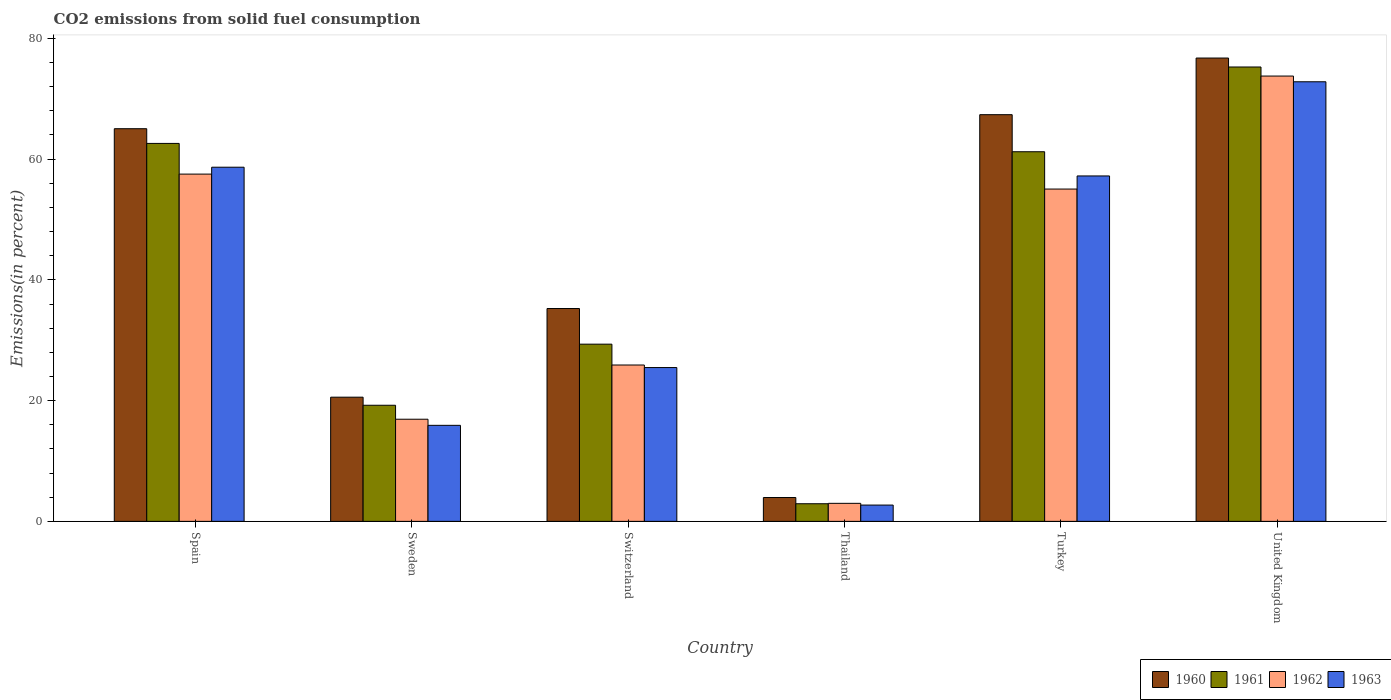How many different coloured bars are there?
Keep it short and to the point. 4. How many groups of bars are there?
Offer a terse response. 6. Are the number of bars per tick equal to the number of legend labels?
Offer a terse response. Yes. In how many cases, is the number of bars for a given country not equal to the number of legend labels?
Offer a very short reply. 0. What is the total CO2 emitted in 1961 in Sweden?
Provide a short and direct response. 19.23. Across all countries, what is the maximum total CO2 emitted in 1960?
Keep it short and to the point. 76.74. Across all countries, what is the minimum total CO2 emitted in 1960?
Provide a short and direct response. 3.95. In which country was the total CO2 emitted in 1962 maximum?
Offer a very short reply. United Kingdom. In which country was the total CO2 emitted in 1963 minimum?
Provide a short and direct response. Thailand. What is the total total CO2 emitted in 1960 in the graph?
Offer a very short reply. 268.92. What is the difference between the total CO2 emitted in 1960 in Switzerland and that in United Kingdom?
Your answer should be compact. -41.49. What is the difference between the total CO2 emitted in 1962 in Thailand and the total CO2 emitted in 1961 in Spain?
Make the answer very short. -59.62. What is the average total CO2 emitted in 1960 per country?
Give a very brief answer. 44.82. What is the difference between the total CO2 emitted of/in 1962 and total CO2 emitted of/in 1963 in Switzerland?
Offer a terse response. 0.42. In how many countries, is the total CO2 emitted in 1961 greater than 68 %?
Offer a terse response. 1. What is the ratio of the total CO2 emitted in 1961 in Switzerland to that in United Kingdom?
Make the answer very short. 0.39. What is the difference between the highest and the second highest total CO2 emitted in 1960?
Keep it short and to the point. -2.33. What is the difference between the highest and the lowest total CO2 emitted in 1960?
Offer a terse response. 72.8. In how many countries, is the total CO2 emitted in 1963 greater than the average total CO2 emitted in 1963 taken over all countries?
Provide a short and direct response. 3. Is the sum of the total CO2 emitted in 1962 in Spain and Sweden greater than the maximum total CO2 emitted in 1960 across all countries?
Your response must be concise. No. Is it the case that in every country, the sum of the total CO2 emitted in 1960 and total CO2 emitted in 1961 is greater than the sum of total CO2 emitted in 1962 and total CO2 emitted in 1963?
Keep it short and to the point. No. What does the 1st bar from the right in Thailand represents?
Your answer should be very brief. 1963. Is it the case that in every country, the sum of the total CO2 emitted in 1962 and total CO2 emitted in 1963 is greater than the total CO2 emitted in 1960?
Keep it short and to the point. Yes. How many bars are there?
Keep it short and to the point. 24. Are all the bars in the graph horizontal?
Offer a terse response. No. What is the difference between two consecutive major ticks on the Y-axis?
Your answer should be very brief. 20. Are the values on the major ticks of Y-axis written in scientific E-notation?
Provide a short and direct response. No. Does the graph contain any zero values?
Provide a succinct answer. No. Does the graph contain grids?
Ensure brevity in your answer.  No. Where does the legend appear in the graph?
Your answer should be very brief. Bottom right. How many legend labels are there?
Offer a terse response. 4. What is the title of the graph?
Keep it short and to the point. CO2 emissions from solid fuel consumption. Does "1979" appear as one of the legend labels in the graph?
Keep it short and to the point. No. What is the label or title of the Y-axis?
Your response must be concise. Emissions(in percent). What is the Emissions(in percent) in 1960 in Spain?
Your response must be concise. 65.04. What is the Emissions(in percent) of 1961 in Spain?
Ensure brevity in your answer.  62.6. What is the Emissions(in percent) of 1962 in Spain?
Provide a short and direct response. 57.52. What is the Emissions(in percent) of 1963 in Spain?
Offer a very short reply. 58.66. What is the Emissions(in percent) of 1960 in Sweden?
Ensure brevity in your answer.  20.57. What is the Emissions(in percent) in 1961 in Sweden?
Ensure brevity in your answer.  19.23. What is the Emissions(in percent) in 1962 in Sweden?
Offer a very short reply. 16.92. What is the Emissions(in percent) of 1963 in Sweden?
Provide a short and direct response. 15.91. What is the Emissions(in percent) in 1960 in Switzerland?
Your response must be concise. 35.26. What is the Emissions(in percent) in 1961 in Switzerland?
Your response must be concise. 29.35. What is the Emissions(in percent) in 1962 in Switzerland?
Offer a terse response. 25.9. What is the Emissions(in percent) in 1963 in Switzerland?
Ensure brevity in your answer.  25.48. What is the Emissions(in percent) in 1960 in Thailand?
Your response must be concise. 3.95. What is the Emissions(in percent) in 1961 in Thailand?
Your answer should be compact. 2.92. What is the Emissions(in percent) of 1962 in Thailand?
Offer a terse response. 2.99. What is the Emissions(in percent) of 1963 in Thailand?
Offer a terse response. 2.7. What is the Emissions(in percent) of 1960 in Turkey?
Offer a terse response. 67.36. What is the Emissions(in percent) in 1961 in Turkey?
Offer a terse response. 61.22. What is the Emissions(in percent) in 1962 in Turkey?
Your answer should be compact. 55.04. What is the Emissions(in percent) in 1963 in Turkey?
Provide a short and direct response. 57.21. What is the Emissions(in percent) in 1960 in United Kingdom?
Make the answer very short. 76.74. What is the Emissions(in percent) of 1961 in United Kingdom?
Your answer should be very brief. 75.26. What is the Emissions(in percent) in 1962 in United Kingdom?
Offer a very short reply. 73.76. What is the Emissions(in percent) of 1963 in United Kingdom?
Offer a terse response. 72.81. Across all countries, what is the maximum Emissions(in percent) in 1960?
Give a very brief answer. 76.74. Across all countries, what is the maximum Emissions(in percent) in 1961?
Ensure brevity in your answer.  75.26. Across all countries, what is the maximum Emissions(in percent) in 1962?
Offer a terse response. 73.76. Across all countries, what is the maximum Emissions(in percent) of 1963?
Your answer should be very brief. 72.81. Across all countries, what is the minimum Emissions(in percent) in 1960?
Your answer should be very brief. 3.95. Across all countries, what is the minimum Emissions(in percent) of 1961?
Give a very brief answer. 2.92. Across all countries, what is the minimum Emissions(in percent) of 1962?
Your response must be concise. 2.99. Across all countries, what is the minimum Emissions(in percent) in 1963?
Offer a very short reply. 2.7. What is the total Emissions(in percent) of 1960 in the graph?
Provide a short and direct response. 268.92. What is the total Emissions(in percent) of 1961 in the graph?
Provide a succinct answer. 250.59. What is the total Emissions(in percent) of 1962 in the graph?
Your answer should be very brief. 232.13. What is the total Emissions(in percent) in 1963 in the graph?
Offer a very short reply. 232.77. What is the difference between the Emissions(in percent) in 1960 in Spain and that in Sweden?
Keep it short and to the point. 44.47. What is the difference between the Emissions(in percent) in 1961 in Spain and that in Sweden?
Keep it short and to the point. 43.37. What is the difference between the Emissions(in percent) in 1962 in Spain and that in Sweden?
Give a very brief answer. 40.6. What is the difference between the Emissions(in percent) of 1963 in Spain and that in Sweden?
Give a very brief answer. 42.75. What is the difference between the Emissions(in percent) of 1960 in Spain and that in Switzerland?
Keep it short and to the point. 29.78. What is the difference between the Emissions(in percent) of 1961 in Spain and that in Switzerland?
Make the answer very short. 33.25. What is the difference between the Emissions(in percent) of 1962 in Spain and that in Switzerland?
Keep it short and to the point. 31.62. What is the difference between the Emissions(in percent) in 1963 in Spain and that in Switzerland?
Offer a terse response. 33.19. What is the difference between the Emissions(in percent) in 1960 in Spain and that in Thailand?
Provide a short and direct response. 61.09. What is the difference between the Emissions(in percent) of 1961 in Spain and that in Thailand?
Your answer should be very brief. 59.69. What is the difference between the Emissions(in percent) of 1962 in Spain and that in Thailand?
Provide a short and direct response. 54.53. What is the difference between the Emissions(in percent) in 1963 in Spain and that in Thailand?
Give a very brief answer. 55.96. What is the difference between the Emissions(in percent) in 1960 in Spain and that in Turkey?
Offer a terse response. -2.33. What is the difference between the Emissions(in percent) in 1961 in Spain and that in Turkey?
Offer a very short reply. 1.38. What is the difference between the Emissions(in percent) of 1962 in Spain and that in Turkey?
Provide a short and direct response. 2.48. What is the difference between the Emissions(in percent) of 1963 in Spain and that in Turkey?
Provide a short and direct response. 1.45. What is the difference between the Emissions(in percent) in 1960 in Spain and that in United Kingdom?
Provide a short and direct response. -11.71. What is the difference between the Emissions(in percent) of 1961 in Spain and that in United Kingdom?
Keep it short and to the point. -12.66. What is the difference between the Emissions(in percent) in 1962 in Spain and that in United Kingdom?
Keep it short and to the point. -16.24. What is the difference between the Emissions(in percent) of 1963 in Spain and that in United Kingdom?
Keep it short and to the point. -14.15. What is the difference between the Emissions(in percent) in 1960 in Sweden and that in Switzerland?
Make the answer very short. -14.69. What is the difference between the Emissions(in percent) of 1961 in Sweden and that in Switzerland?
Your answer should be very brief. -10.12. What is the difference between the Emissions(in percent) in 1962 in Sweden and that in Switzerland?
Your answer should be compact. -8.98. What is the difference between the Emissions(in percent) in 1963 in Sweden and that in Switzerland?
Offer a terse response. -9.57. What is the difference between the Emissions(in percent) in 1960 in Sweden and that in Thailand?
Your response must be concise. 16.62. What is the difference between the Emissions(in percent) of 1961 in Sweden and that in Thailand?
Make the answer very short. 16.31. What is the difference between the Emissions(in percent) in 1962 in Sweden and that in Thailand?
Ensure brevity in your answer.  13.93. What is the difference between the Emissions(in percent) in 1963 in Sweden and that in Thailand?
Keep it short and to the point. 13.21. What is the difference between the Emissions(in percent) of 1960 in Sweden and that in Turkey?
Offer a terse response. -46.8. What is the difference between the Emissions(in percent) of 1961 in Sweden and that in Turkey?
Keep it short and to the point. -41.99. What is the difference between the Emissions(in percent) of 1962 in Sweden and that in Turkey?
Your answer should be compact. -38.13. What is the difference between the Emissions(in percent) of 1963 in Sweden and that in Turkey?
Provide a short and direct response. -41.31. What is the difference between the Emissions(in percent) of 1960 in Sweden and that in United Kingdom?
Keep it short and to the point. -56.18. What is the difference between the Emissions(in percent) of 1961 in Sweden and that in United Kingdom?
Give a very brief answer. -56.03. What is the difference between the Emissions(in percent) in 1962 in Sweden and that in United Kingdom?
Provide a short and direct response. -56.84. What is the difference between the Emissions(in percent) in 1963 in Sweden and that in United Kingdom?
Your answer should be very brief. -56.91. What is the difference between the Emissions(in percent) of 1960 in Switzerland and that in Thailand?
Your answer should be very brief. 31.31. What is the difference between the Emissions(in percent) in 1961 in Switzerland and that in Thailand?
Make the answer very short. 26.43. What is the difference between the Emissions(in percent) in 1962 in Switzerland and that in Thailand?
Offer a very short reply. 22.91. What is the difference between the Emissions(in percent) in 1963 in Switzerland and that in Thailand?
Offer a very short reply. 22.78. What is the difference between the Emissions(in percent) of 1960 in Switzerland and that in Turkey?
Your response must be concise. -32.11. What is the difference between the Emissions(in percent) in 1961 in Switzerland and that in Turkey?
Keep it short and to the point. -31.87. What is the difference between the Emissions(in percent) of 1962 in Switzerland and that in Turkey?
Keep it short and to the point. -29.14. What is the difference between the Emissions(in percent) in 1963 in Switzerland and that in Turkey?
Ensure brevity in your answer.  -31.74. What is the difference between the Emissions(in percent) in 1960 in Switzerland and that in United Kingdom?
Offer a very short reply. -41.49. What is the difference between the Emissions(in percent) of 1961 in Switzerland and that in United Kingdom?
Your answer should be compact. -45.91. What is the difference between the Emissions(in percent) of 1962 in Switzerland and that in United Kingdom?
Make the answer very short. -47.86. What is the difference between the Emissions(in percent) of 1963 in Switzerland and that in United Kingdom?
Provide a short and direct response. -47.34. What is the difference between the Emissions(in percent) of 1960 in Thailand and that in Turkey?
Keep it short and to the point. -63.42. What is the difference between the Emissions(in percent) of 1961 in Thailand and that in Turkey?
Provide a succinct answer. -58.31. What is the difference between the Emissions(in percent) in 1962 in Thailand and that in Turkey?
Give a very brief answer. -52.06. What is the difference between the Emissions(in percent) of 1963 in Thailand and that in Turkey?
Offer a very short reply. -54.52. What is the difference between the Emissions(in percent) of 1960 in Thailand and that in United Kingdom?
Offer a terse response. -72.8. What is the difference between the Emissions(in percent) in 1961 in Thailand and that in United Kingdom?
Provide a succinct answer. -72.34. What is the difference between the Emissions(in percent) in 1962 in Thailand and that in United Kingdom?
Your answer should be compact. -70.77. What is the difference between the Emissions(in percent) in 1963 in Thailand and that in United Kingdom?
Provide a succinct answer. -70.11. What is the difference between the Emissions(in percent) of 1960 in Turkey and that in United Kingdom?
Keep it short and to the point. -9.38. What is the difference between the Emissions(in percent) of 1961 in Turkey and that in United Kingdom?
Offer a very short reply. -14.04. What is the difference between the Emissions(in percent) in 1962 in Turkey and that in United Kingdom?
Offer a terse response. -18.72. What is the difference between the Emissions(in percent) in 1963 in Turkey and that in United Kingdom?
Make the answer very short. -15.6. What is the difference between the Emissions(in percent) of 1960 in Spain and the Emissions(in percent) of 1961 in Sweden?
Give a very brief answer. 45.81. What is the difference between the Emissions(in percent) of 1960 in Spain and the Emissions(in percent) of 1962 in Sweden?
Offer a terse response. 48.12. What is the difference between the Emissions(in percent) of 1960 in Spain and the Emissions(in percent) of 1963 in Sweden?
Offer a terse response. 49.13. What is the difference between the Emissions(in percent) in 1961 in Spain and the Emissions(in percent) in 1962 in Sweden?
Your answer should be compact. 45.69. What is the difference between the Emissions(in percent) in 1961 in Spain and the Emissions(in percent) in 1963 in Sweden?
Make the answer very short. 46.7. What is the difference between the Emissions(in percent) of 1962 in Spain and the Emissions(in percent) of 1963 in Sweden?
Your response must be concise. 41.61. What is the difference between the Emissions(in percent) of 1960 in Spain and the Emissions(in percent) of 1961 in Switzerland?
Offer a very short reply. 35.69. What is the difference between the Emissions(in percent) in 1960 in Spain and the Emissions(in percent) in 1962 in Switzerland?
Your answer should be very brief. 39.14. What is the difference between the Emissions(in percent) in 1960 in Spain and the Emissions(in percent) in 1963 in Switzerland?
Provide a succinct answer. 39.56. What is the difference between the Emissions(in percent) of 1961 in Spain and the Emissions(in percent) of 1962 in Switzerland?
Ensure brevity in your answer.  36.7. What is the difference between the Emissions(in percent) of 1961 in Spain and the Emissions(in percent) of 1963 in Switzerland?
Your response must be concise. 37.13. What is the difference between the Emissions(in percent) of 1962 in Spain and the Emissions(in percent) of 1963 in Switzerland?
Provide a short and direct response. 32.04. What is the difference between the Emissions(in percent) of 1960 in Spain and the Emissions(in percent) of 1961 in Thailand?
Offer a terse response. 62.12. What is the difference between the Emissions(in percent) in 1960 in Spain and the Emissions(in percent) in 1962 in Thailand?
Offer a very short reply. 62.05. What is the difference between the Emissions(in percent) of 1960 in Spain and the Emissions(in percent) of 1963 in Thailand?
Ensure brevity in your answer.  62.34. What is the difference between the Emissions(in percent) of 1961 in Spain and the Emissions(in percent) of 1962 in Thailand?
Keep it short and to the point. 59.62. What is the difference between the Emissions(in percent) of 1961 in Spain and the Emissions(in percent) of 1963 in Thailand?
Make the answer very short. 59.91. What is the difference between the Emissions(in percent) of 1962 in Spain and the Emissions(in percent) of 1963 in Thailand?
Provide a short and direct response. 54.82. What is the difference between the Emissions(in percent) of 1960 in Spain and the Emissions(in percent) of 1961 in Turkey?
Your answer should be very brief. 3.81. What is the difference between the Emissions(in percent) in 1960 in Spain and the Emissions(in percent) in 1962 in Turkey?
Provide a succinct answer. 9.99. What is the difference between the Emissions(in percent) of 1960 in Spain and the Emissions(in percent) of 1963 in Turkey?
Provide a short and direct response. 7.82. What is the difference between the Emissions(in percent) of 1961 in Spain and the Emissions(in percent) of 1962 in Turkey?
Your response must be concise. 7.56. What is the difference between the Emissions(in percent) in 1961 in Spain and the Emissions(in percent) in 1963 in Turkey?
Make the answer very short. 5.39. What is the difference between the Emissions(in percent) of 1962 in Spain and the Emissions(in percent) of 1963 in Turkey?
Provide a succinct answer. 0.31. What is the difference between the Emissions(in percent) of 1960 in Spain and the Emissions(in percent) of 1961 in United Kingdom?
Your response must be concise. -10.22. What is the difference between the Emissions(in percent) in 1960 in Spain and the Emissions(in percent) in 1962 in United Kingdom?
Provide a succinct answer. -8.72. What is the difference between the Emissions(in percent) of 1960 in Spain and the Emissions(in percent) of 1963 in United Kingdom?
Your answer should be compact. -7.78. What is the difference between the Emissions(in percent) in 1961 in Spain and the Emissions(in percent) in 1962 in United Kingdom?
Keep it short and to the point. -11.16. What is the difference between the Emissions(in percent) in 1961 in Spain and the Emissions(in percent) in 1963 in United Kingdom?
Provide a short and direct response. -10.21. What is the difference between the Emissions(in percent) of 1962 in Spain and the Emissions(in percent) of 1963 in United Kingdom?
Offer a very short reply. -15.29. What is the difference between the Emissions(in percent) of 1960 in Sweden and the Emissions(in percent) of 1961 in Switzerland?
Keep it short and to the point. -8.78. What is the difference between the Emissions(in percent) of 1960 in Sweden and the Emissions(in percent) of 1962 in Switzerland?
Provide a succinct answer. -5.33. What is the difference between the Emissions(in percent) of 1960 in Sweden and the Emissions(in percent) of 1963 in Switzerland?
Keep it short and to the point. -4.91. What is the difference between the Emissions(in percent) of 1961 in Sweden and the Emissions(in percent) of 1962 in Switzerland?
Give a very brief answer. -6.67. What is the difference between the Emissions(in percent) in 1961 in Sweden and the Emissions(in percent) in 1963 in Switzerland?
Offer a very short reply. -6.24. What is the difference between the Emissions(in percent) in 1962 in Sweden and the Emissions(in percent) in 1963 in Switzerland?
Your answer should be very brief. -8.56. What is the difference between the Emissions(in percent) of 1960 in Sweden and the Emissions(in percent) of 1961 in Thailand?
Offer a terse response. 17.65. What is the difference between the Emissions(in percent) in 1960 in Sweden and the Emissions(in percent) in 1962 in Thailand?
Your answer should be very brief. 17.58. What is the difference between the Emissions(in percent) in 1960 in Sweden and the Emissions(in percent) in 1963 in Thailand?
Provide a short and direct response. 17.87. What is the difference between the Emissions(in percent) in 1961 in Sweden and the Emissions(in percent) in 1962 in Thailand?
Provide a succinct answer. 16.25. What is the difference between the Emissions(in percent) of 1961 in Sweden and the Emissions(in percent) of 1963 in Thailand?
Offer a very short reply. 16.53. What is the difference between the Emissions(in percent) in 1962 in Sweden and the Emissions(in percent) in 1963 in Thailand?
Provide a succinct answer. 14.22. What is the difference between the Emissions(in percent) in 1960 in Sweden and the Emissions(in percent) in 1961 in Turkey?
Your response must be concise. -40.66. What is the difference between the Emissions(in percent) in 1960 in Sweden and the Emissions(in percent) in 1962 in Turkey?
Your answer should be very brief. -34.47. What is the difference between the Emissions(in percent) in 1960 in Sweden and the Emissions(in percent) in 1963 in Turkey?
Offer a very short reply. -36.65. What is the difference between the Emissions(in percent) of 1961 in Sweden and the Emissions(in percent) of 1962 in Turkey?
Your answer should be compact. -35.81. What is the difference between the Emissions(in percent) in 1961 in Sweden and the Emissions(in percent) in 1963 in Turkey?
Ensure brevity in your answer.  -37.98. What is the difference between the Emissions(in percent) in 1962 in Sweden and the Emissions(in percent) in 1963 in Turkey?
Offer a very short reply. -40.3. What is the difference between the Emissions(in percent) of 1960 in Sweden and the Emissions(in percent) of 1961 in United Kingdom?
Offer a terse response. -54.69. What is the difference between the Emissions(in percent) in 1960 in Sweden and the Emissions(in percent) in 1962 in United Kingdom?
Give a very brief answer. -53.19. What is the difference between the Emissions(in percent) in 1960 in Sweden and the Emissions(in percent) in 1963 in United Kingdom?
Provide a short and direct response. -52.24. What is the difference between the Emissions(in percent) in 1961 in Sweden and the Emissions(in percent) in 1962 in United Kingdom?
Ensure brevity in your answer.  -54.53. What is the difference between the Emissions(in percent) of 1961 in Sweden and the Emissions(in percent) of 1963 in United Kingdom?
Provide a short and direct response. -53.58. What is the difference between the Emissions(in percent) of 1962 in Sweden and the Emissions(in percent) of 1963 in United Kingdom?
Offer a very short reply. -55.9. What is the difference between the Emissions(in percent) of 1960 in Switzerland and the Emissions(in percent) of 1961 in Thailand?
Provide a succinct answer. 32.34. What is the difference between the Emissions(in percent) of 1960 in Switzerland and the Emissions(in percent) of 1962 in Thailand?
Offer a terse response. 32.27. What is the difference between the Emissions(in percent) in 1960 in Switzerland and the Emissions(in percent) in 1963 in Thailand?
Your answer should be compact. 32.56. What is the difference between the Emissions(in percent) of 1961 in Switzerland and the Emissions(in percent) of 1962 in Thailand?
Provide a short and direct response. 26.37. What is the difference between the Emissions(in percent) of 1961 in Switzerland and the Emissions(in percent) of 1963 in Thailand?
Make the answer very short. 26.65. What is the difference between the Emissions(in percent) in 1962 in Switzerland and the Emissions(in percent) in 1963 in Thailand?
Offer a very short reply. 23.2. What is the difference between the Emissions(in percent) in 1960 in Switzerland and the Emissions(in percent) in 1961 in Turkey?
Keep it short and to the point. -25.97. What is the difference between the Emissions(in percent) of 1960 in Switzerland and the Emissions(in percent) of 1962 in Turkey?
Provide a short and direct response. -19.79. What is the difference between the Emissions(in percent) of 1960 in Switzerland and the Emissions(in percent) of 1963 in Turkey?
Offer a terse response. -21.96. What is the difference between the Emissions(in percent) of 1961 in Switzerland and the Emissions(in percent) of 1962 in Turkey?
Give a very brief answer. -25.69. What is the difference between the Emissions(in percent) of 1961 in Switzerland and the Emissions(in percent) of 1963 in Turkey?
Keep it short and to the point. -27.86. What is the difference between the Emissions(in percent) in 1962 in Switzerland and the Emissions(in percent) in 1963 in Turkey?
Your response must be concise. -31.32. What is the difference between the Emissions(in percent) of 1960 in Switzerland and the Emissions(in percent) of 1961 in United Kingdom?
Offer a very short reply. -40.01. What is the difference between the Emissions(in percent) of 1960 in Switzerland and the Emissions(in percent) of 1962 in United Kingdom?
Your answer should be very brief. -38.51. What is the difference between the Emissions(in percent) in 1960 in Switzerland and the Emissions(in percent) in 1963 in United Kingdom?
Offer a very short reply. -37.56. What is the difference between the Emissions(in percent) in 1961 in Switzerland and the Emissions(in percent) in 1962 in United Kingdom?
Give a very brief answer. -44.41. What is the difference between the Emissions(in percent) of 1961 in Switzerland and the Emissions(in percent) of 1963 in United Kingdom?
Give a very brief answer. -43.46. What is the difference between the Emissions(in percent) of 1962 in Switzerland and the Emissions(in percent) of 1963 in United Kingdom?
Offer a very short reply. -46.91. What is the difference between the Emissions(in percent) in 1960 in Thailand and the Emissions(in percent) in 1961 in Turkey?
Make the answer very short. -57.28. What is the difference between the Emissions(in percent) in 1960 in Thailand and the Emissions(in percent) in 1962 in Turkey?
Offer a terse response. -51.09. What is the difference between the Emissions(in percent) in 1960 in Thailand and the Emissions(in percent) in 1963 in Turkey?
Keep it short and to the point. -53.27. What is the difference between the Emissions(in percent) in 1961 in Thailand and the Emissions(in percent) in 1962 in Turkey?
Your answer should be compact. -52.13. What is the difference between the Emissions(in percent) in 1961 in Thailand and the Emissions(in percent) in 1963 in Turkey?
Offer a terse response. -54.3. What is the difference between the Emissions(in percent) of 1962 in Thailand and the Emissions(in percent) of 1963 in Turkey?
Your answer should be compact. -54.23. What is the difference between the Emissions(in percent) of 1960 in Thailand and the Emissions(in percent) of 1961 in United Kingdom?
Give a very brief answer. -71.31. What is the difference between the Emissions(in percent) of 1960 in Thailand and the Emissions(in percent) of 1962 in United Kingdom?
Offer a terse response. -69.81. What is the difference between the Emissions(in percent) of 1960 in Thailand and the Emissions(in percent) of 1963 in United Kingdom?
Your response must be concise. -68.86. What is the difference between the Emissions(in percent) in 1961 in Thailand and the Emissions(in percent) in 1962 in United Kingdom?
Your answer should be compact. -70.84. What is the difference between the Emissions(in percent) in 1961 in Thailand and the Emissions(in percent) in 1963 in United Kingdom?
Provide a succinct answer. -69.9. What is the difference between the Emissions(in percent) in 1962 in Thailand and the Emissions(in percent) in 1963 in United Kingdom?
Provide a succinct answer. -69.83. What is the difference between the Emissions(in percent) in 1960 in Turkey and the Emissions(in percent) in 1961 in United Kingdom?
Make the answer very short. -7.9. What is the difference between the Emissions(in percent) in 1960 in Turkey and the Emissions(in percent) in 1962 in United Kingdom?
Offer a very short reply. -6.4. What is the difference between the Emissions(in percent) in 1960 in Turkey and the Emissions(in percent) in 1963 in United Kingdom?
Keep it short and to the point. -5.45. What is the difference between the Emissions(in percent) in 1961 in Turkey and the Emissions(in percent) in 1962 in United Kingdom?
Make the answer very short. -12.54. What is the difference between the Emissions(in percent) in 1961 in Turkey and the Emissions(in percent) in 1963 in United Kingdom?
Your answer should be compact. -11.59. What is the difference between the Emissions(in percent) in 1962 in Turkey and the Emissions(in percent) in 1963 in United Kingdom?
Keep it short and to the point. -17.77. What is the average Emissions(in percent) in 1960 per country?
Provide a short and direct response. 44.82. What is the average Emissions(in percent) in 1961 per country?
Make the answer very short. 41.77. What is the average Emissions(in percent) of 1962 per country?
Provide a succinct answer. 38.69. What is the average Emissions(in percent) in 1963 per country?
Offer a very short reply. 38.8. What is the difference between the Emissions(in percent) in 1960 and Emissions(in percent) in 1961 in Spain?
Your answer should be compact. 2.43. What is the difference between the Emissions(in percent) in 1960 and Emissions(in percent) in 1962 in Spain?
Your response must be concise. 7.52. What is the difference between the Emissions(in percent) in 1960 and Emissions(in percent) in 1963 in Spain?
Your response must be concise. 6.38. What is the difference between the Emissions(in percent) of 1961 and Emissions(in percent) of 1962 in Spain?
Your answer should be compact. 5.08. What is the difference between the Emissions(in percent) of 1961 and Emissions(in percent) of 1963 in Spain?
Offer a terse response. 3.94. What is the difference between the Emissions(in percent) in 1962 and Emissions(in percent) in 1963 in Spain?
Keep it short and to the point. -1.14. What is the difference between the Emissions(in percent) of 1960 and Emissions(in percent) of 1961 in Sweden?
Give a very brief answer. 1.34. What is the difference between the Emissions(in percent) of 1960 and Emissions(in percent) of 1962 in Sweden?
Your answer should be very brief. 3.65. What is the difference between the Emissions(in percent) of 1960 and Emissions(in percent) of 1963 in Sweden?
Your answer should be compact. 4.66. What is the difference between the Emissions(in percent) of 1961 and Emissions(in percent) of 1962 in Sweden?
Offer a terse response. 2.31. What is the difference between the Emissions(in percent) of 1961 and Emissions(in percent) of 1963 in Sweden?
Make the answer very short. 3.32. What is the difference between the Emissions(in percent) of 1962 and Emissions(in percent) of 1963 in Sweden?
Provide a short and direct response. 1.01. What is the difference between the Emissions(in percent) in 1960 and Emissions(in percent) in 1961 in Switzerland?
Your answer should be very brief. 5.9. What is the difference between the Emissions(in percent) in 1960 and Emissions(in percent) in 1962 in Switzerland?
Offer a very short reply. 9.36. What is the difference between the Emissions(in percent) of 1960 and Emissions(in percent) of 1963 in Switzerland?
Offer a very short reply. 9.78. What is the difference between the Emissions(in percent) in 1961 and Emissions(in percent) in 1962 in Switzerland?
Your answer should be very brief. 3.45. What is the difference between the Emissions(in percent) in 1961 and Emissions(in percent) in 1963 in Switzerland?
Provide a short and direct response. 3.88. What is the difference between the Emissions(in percent) of 1962 and Emissions(in percent) of 1963 in Switzerland?
Your answer should be very brief. 0.42. What is the difference between the Emissions(in percent) in 1960 and Emissions(in percent) in 1961 in Thailand?
Make the answer very short. 1.03. What is the difference between the Emissions(in percent) of 1960 and Emissions(in percent) of 1962 in Thailand?
Offer a very short reply. 0.96. What is the difference between the Emissions(in percent) of 1960 and Emissions(in percent) of 1963 in Thailand?
Offer a terse response. 1.25. What is the difference between the Emissions(in percent) in 1961 and Emissions(in percent) in 1962 in Thailand?
Give a very brief answer. -0.07. What is the difference between the Emissions(in percent) of 1961 and Emissions(in percent) of 1963 in Thailand?
Your answer should be very brief. 0.22. What is the difference between the Emissions(in percent) of 1962 and Emissions(in percent) of 1963 in Thailand?
Ensure brevity in your answer.  0.29. What is the difference between the Emissions(in percent) of 1960 and Emissions(in percent) of 1961 in Turkey?
Ensure brevity in your answer.  6.14. What is the difference between the Emissions(in percent) in 1960 and Emissions(in percent) in 1962 in Turkey?
Give a very brief answer. 12.32. What is the difference between the Emissions(in percent) in 1960 and Emissions(in percent) in 1963 in Turkey?
Keep it short and to the point. 10.15. What is the difference between the Emissions(in percent) of 1961 and Emissions(in percent) of 1962 in Turkey?
Give a very brief answer. 6.18. What is the difference between the Emissions(in percent) of 1961 and Emissions(in percent) of 1963 in Turkey?
Your response must be concise. 4.01. What is the difference between the Emissions(in percent) of 1962 and Emissions(in percent) of 1963 in Turkey?
Provide a succinct answer. -2.17. What is the difference between the Emissions(in percent) in 1960 and Emissions(in percent) in 1961 in United Kingdom?
Provide a short and direct response. 1.48. What is the difference between the Emissions(in percent) of 1960 and Emissions(in percent) of 1962 in United Kingdom?
Your answer should be very brief. 2.98. What is the difference between the Emissions(in percent) in 1960 and Emissions(in percent) in 1963 in United Kingdom?
Your response must be concise. 3.93. What is the difference between the Emissions(in percent) in 1961 and Emissions(in percent) in 1962 in United Kingdom?
Offer a terse response. 1.5. What is the difference between the Emissions(in percent) of 1961 and Emissions(in percent) of 1963 in United Kingdom?
Make the answer very short. 2.45. What is the difference between the Emissions(in percent) in 1962 and Emissions(in percent) in 1963 in United Kingdom?
Offer a very short reply. 0.95. What is the ratio of the Emissions(in percent) of 1960 in Spain to that in Sweden?
Your response must be concise. 3.16. What is the ratio of the Emissions(in percent) in 1961 in Spain to that in Sweden?
Your answer should be very brief. 3.26. What is the ratio of the Emissions(in percent) in 1962 in Spain to that in Sweden?
Offer a terse response. 3.4. What is the ratio of the Emissions(in percent) in 1963 in Spain to that in Sweden?
Provide a short and direct response. 3.69. What is the ratio of the Emissions(in percent) of 1960 in Spain to that in Switzerland?
Your answer should be very brief. 1.84. What is the ratio of the Emissions(in percent) in 1961 in Spain to that in Switzerland?
Ensure brevity in your answer.  2.13. What is the ratio of the Emissions(in percent) of 1962 in Spain to that in Switzerland?
Offer a very short reply. 2.22. What is the ratio of the Emissions(in percent) of 1963 in Spain to that in Switzerland?
Offer a terse response. 2.3. What is the ratio of the Emissions(in percent) in 1960 in Spain to that in Thailand?
Offer a terse response. 16.47. What is the ratio of the Emissions(in percent) of 1961 in Spain to that in Thailand?
Provide a succinct answer. 21.46. What is the ratio of the Emissions(in percent) of 1962 in Spain to that in Thailand?
Your answer should be compact. 19.26. What is the ratio of the Emissions(in percent) of 1963 in Spain to that in Thailand?
Provide a short and direct response. 21.73. What is the ratio of the Emissions(in percent) in 1960 in Spain to that in Turkey?
Keep it short and to the point. 0.97. What is the ratio of the Emissions(in percent) in 1961 in Spain to that in Turkey?
Provide a short and direct response. 1.02. What is the ratio of the Emissions(in percent) of 1962 in Spain to that in Turkey?
Offer a very short reply. 1.04. What is the ratio of the Emissions(in percent) of 1963 in Spain to that in Turkey?
Provide a succinct answer. 1.03. What is the ratio of the Emissions(in percent) in 1960 in Spain to that in United Kingdom?
Your answer should be very brief. 0.85. What is the ratio of the Emissions(in percent) of 1961 in Spain to that in United Kingdom?
Give a very brief answer. 0.83. What is the ratio of the Emissions(in percent) of 1962 in Spain to that in United Kingdom?
Provide a succinct answer. 0.78. What is the ratio of the Emissions(in percent) in 1963 in Spain to that in United Kingdom?
Your response must be concise. 0.81. What is the ratio of the Emissions(in percent) of 1960 in Sweden to that in Switzerland?
Ensure brevity in your answer.  0.58. What is the ratio of the Emissions(in percent) in 1961 in Sweden to that in Switzerland?
Give a very brief answer. 0.66. What is the ratio of the Emissions(in percent) in 1962 in Sweden to that in Switzerland?
Ensure brevity in your answer.  0.65. What is the ratio of the Emissions(in percent) in 1963 in Sweden to that in Switzerland?
Offer a very short reply. 0.62. What is the ratio of the Emissions(in percent) of 1960 in Sweden to that in Thailand?
Offer a terse response. 5.21. What is the ratio of the Emissions(in percent) in 1961 in Sweden to that in Thailand?
Your response must be concise. 6.59. What is the ratio of the Emissions(in percent) in 1962 in Sweden to that in Thailand?
Provide a short and direct response. 5.67. What is the ratio of the Emissions(in percent) of 1963 in Sweden to that in Thailand?
Provide a short and direct response. 5.89. What is the ratio of the Emissions(in percent) in 1960 in Sweden to that in Turkey?
Your answer should be compact. 0.31. What is the ratio of the Emissions(in percent) of 1961 in Sweden to that in Turkey?
Your response must be concise. 0.31. What is the ratio of the Emissions(in percent) in 1962 in Sweden to that in Turkey?
Your response must be concise. 0.31. What is the ratio of the Emissions(in percent) of 1963 in Sweden to that in Turkey?
Your response must be concise. 0.28. What is the ratio of the Emissions(in percent) of 1960 in Sweden to that in United Kingdom?
Your response must be concise. 0.27. What is the ratio of the Emissions(in percent) in 1961 in Sweden to that in United Kingdom?
Provide a succinct answer. 0.26. What is the ratio of the Emissions(in percent) in 1962 in Sweden to that in United Kingdom?
Provide a succinct answer. 0.23. What is the ratio of the Emissions(in percent) in 1963 in Sweden to that in United Kingdom?
Your answer should be compact. 0.22. What is the ratio of the Emissions(in percent) in 1960 in Switzerland to that in Thailand?
Provide a short and direct response. 8.93. What is the ratio of the Emissions(in percent) of 1961 in Switzerland to that in Thailand?
Make the answer very short. 10.06. What is the ratio of the Emissions(in percent) of 1962 in Switzerland to that in Thailand?
Give a very brief answer. 8.67. What is the ratio of the Emissions(in percent) of 1963 in Switzerland to that in Thailand?
Provide a short and direct response. 9.44. What is the ratio of the Emissions(in percent) in 1960 in Switzerland to that in Turkey?
Your response must be concise. 0.52. What is the ratio of the Emissions(in percent) in 1961 in Switzerland to that in Turkey?
Provide a short and direct response. 0.48. What is the ratio of the Emissions(in percent) in 1962 in Switzerland to that in Turkey?
Make the answer very short. 0.47. What is the ratio of the Emissions(in percent) in 1963 in Switzerland to that in Turkey?
Your response must be concise. 0.45. What is the ratio of the Emissions(in percent) of 1960 in Switzerland to that in United Kingdom?
Your answer should be compact. 0.46. What is the ratio of the Emissions(in percent) of 1961 in Switzerland to that in United Kingdom?
Provide a short and direct response. 0.39. What is the ratio of the Emissions(in percent) in 1962 in Switzerland to that in United Kingdom?
Offer a terse response. 0.35. What is the ratio of the Emissions(in percent) of 1963 in Switzerland to that in United Kingdom?
Your answer should be very brief. 0.35. What is the ratio of the Emissions(in percent) of 1960 in Thailand to that in Turkey?
Provide a succinct answer. 0.06. What is the ratio of the Emissions(in percent) of 1961 in Thailand to that in Turkey?
Your answer should be very brief. 0.05. What is the ratio of the Emissions(in percent) in 1962 in Thailand to that in Turkey?
Your answer should be very brief. 0.05. What is the ratio of the Emissions(in percent) of 1963 in Thailand to that in Turkey?
Make the answer very short. 0.05. What is the ratio of the Emissions(in percent) in 1960 in Thailand to that in United Kingdom?
Keep it short and to the point. 0.05. What is the ratio of the Emissions(in percent) in 1961 in Thailand to that in United Kingdom?
Provide a succinct answer. 0.04. What is the ratio of the Emissions(in percent) of 1962 in Thailand to that in United Kingdom?
Offer a terse response. 0.04. What is the ratio of the Emissions(in percent) in 1963 in Thailand to that in United Kingdom?
Offer a terse response. 0.04. What is the ratio of the Emissions(in percent) of 1960 in Turkey to that in United Kingdom?
Ensure brevity in your answer.  0.88. What is the ratio of the Emissions(in percent) in 1961 in Turkey to that in United Kingdom?
Keep it short and to the point. 0.81. What is the ratio of the Emissions(in percent) in 1962 in Turkey to that in United Kingdom?
Your response must be concise. 0.75. What is the ratio of the Emissions(in percent) in 1963 in Turkey to that in United Kingdom?
Provide a short and direct response. 0.79. What is the difference between the highest and the second highest Emissions(in percent) in 1960?
Offer a very short reply. 9.38. What is the difference between the highest and the second highest Emissions(in percent) of 1961?
Make the answer very short. 12.66. What is the difference between the highest and the second highest Emissions(in percent) of 1962?
Provide a short and direct response. 16.24. What is the difference between the highest and the second highest Emissions(in percent) in 1963?
Your response must be concise. 14.15. What is the difference between the highest and the lowest Emissions(in percent) in 1960?
Give a very brief answer. 72.8. What is the difference between the highest and the lowest Emissions(in percent) of 1961?
Offer a very short reply. 72.34. What is the difference between the highest and the lowest Emissions(in percent) in 1962?
Give a very brief answer. 70.77. What is the difference between the highest and the lowest Emissions(in percent) in 1963?
Your answer should be very brief. 70.11. 